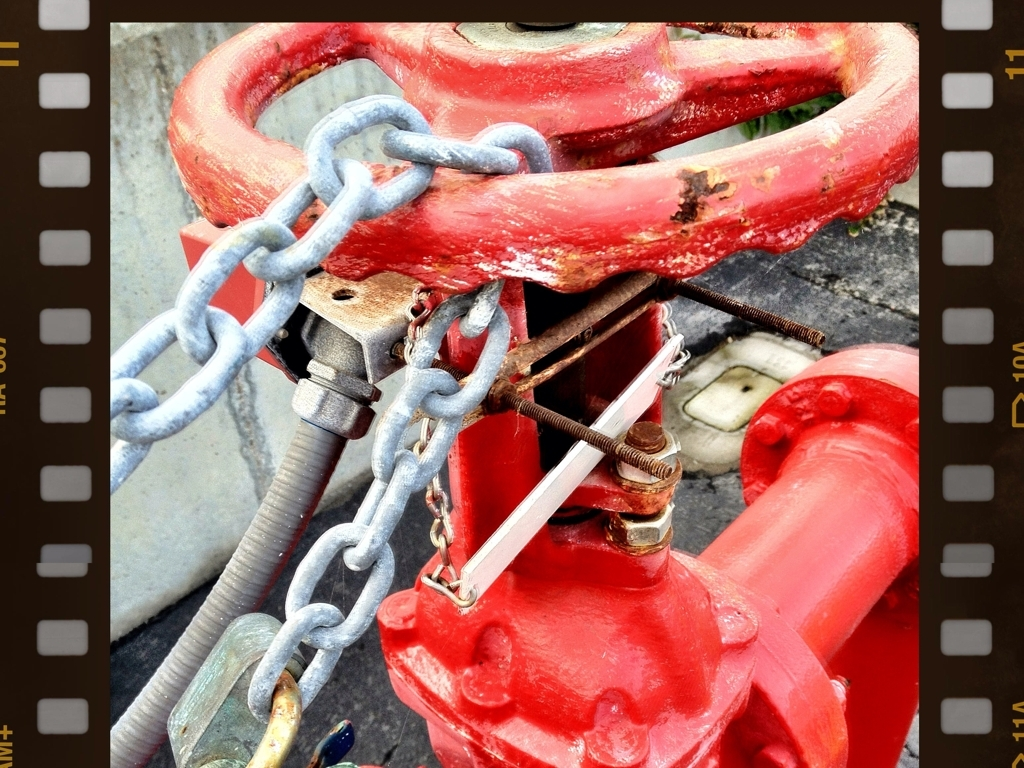Is it difficult to see scratches on the fire hydrant in the image? Scratches on the fire hydrant are moderately visible due to the contrasting colors; the fire hydrant's bright red paint has chipped off in several areas, exposing the duller metal underneath, which makes the scratches and signs of wear stand out to the observer. 